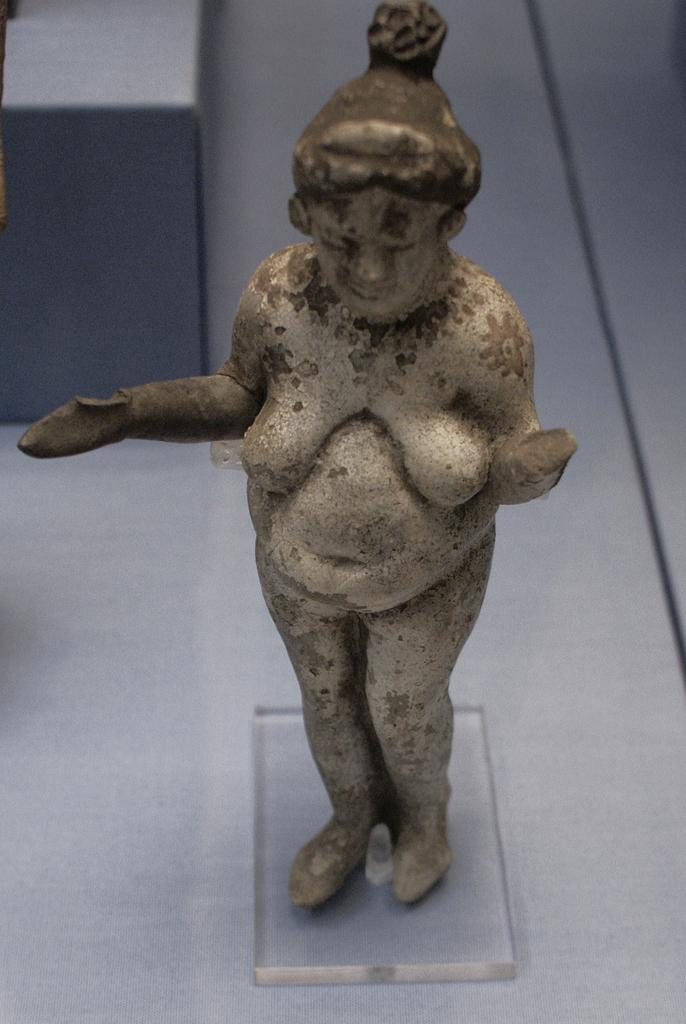What is the main subject of the image? There is a statue of a woman in the image. What is the statue standing on? The statue is on a glass surface. What is supporting the glass surface? There is a table beneath the glass surface. What else can be seen on the table? There is an object on the table. Can you describe the fight between the statue and the object on the table? There is no fight depicted in the image; the statue and the object are both stationary. What color is the eye of the statue in the image? The image does not show the statue's eye, as it is a statue and does not have eyes. 